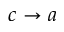Convert formula to latex. <formula><loc_0><loc_0><loc_500><loc_500>c \to a</formula> 